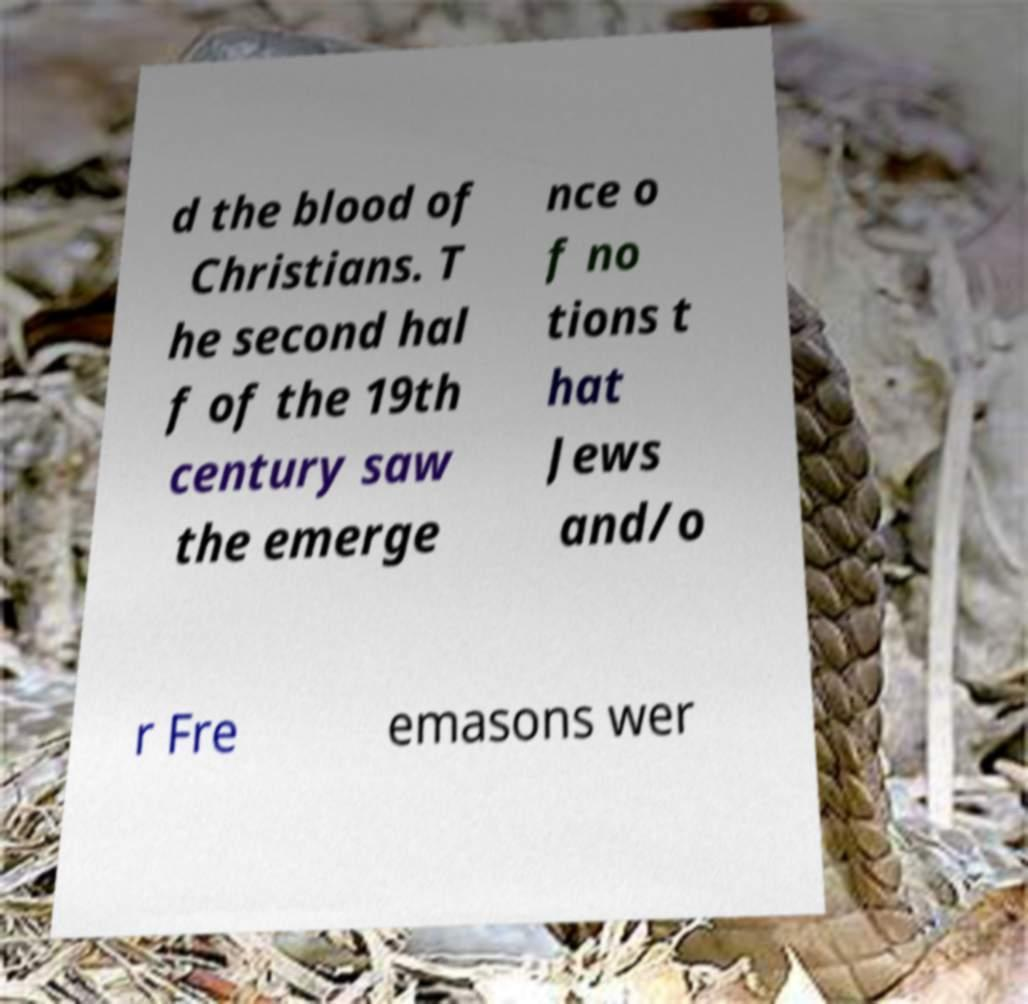I need the written content from this picture converted into text. Can you do that? d the blood of Christians. T he second hal f of the 19th century saw the emerge nce o f no tions t hat Jews and/o r Fre emasons wer 